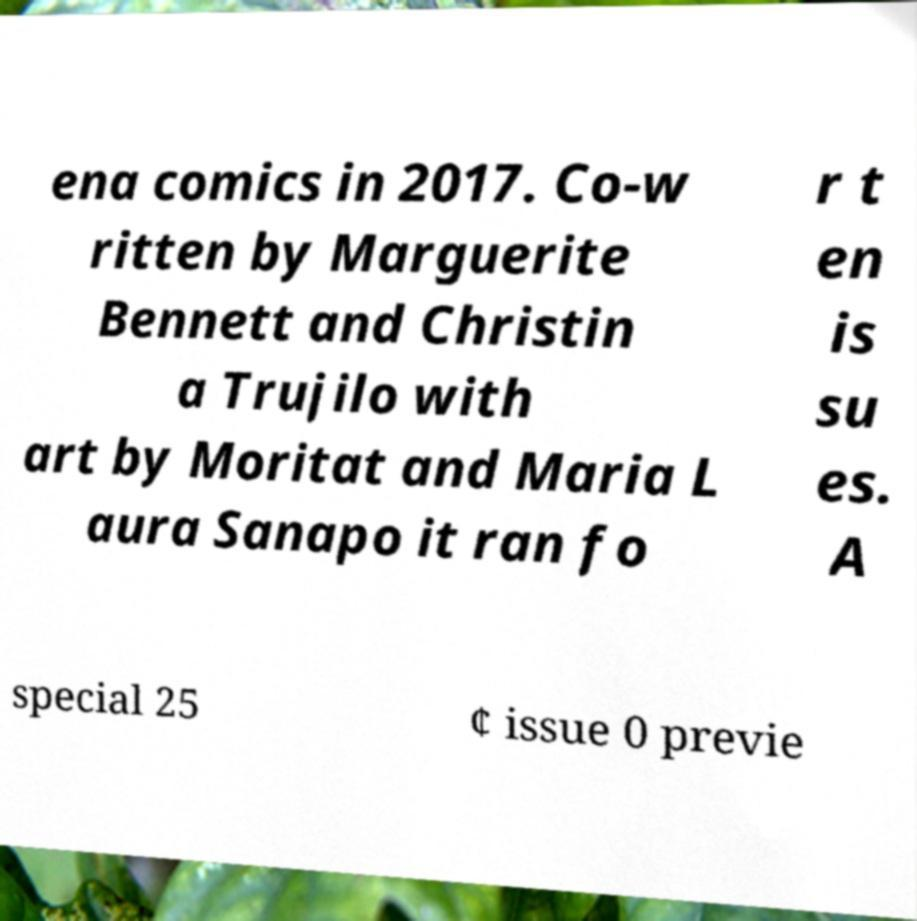Please identify and transcribe the text found in this image. ena comics in 2017. Co-w ritten by Marguerite Bennett and Christin a Trujilo with art by Moritat and Maria L aura Sanapo it ran fo r t en is su es. A special 25 ¢ issue 0 previe 